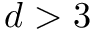<formula> <loc_0><loc_0><loc_500><loc_500>d > 3</formula> 